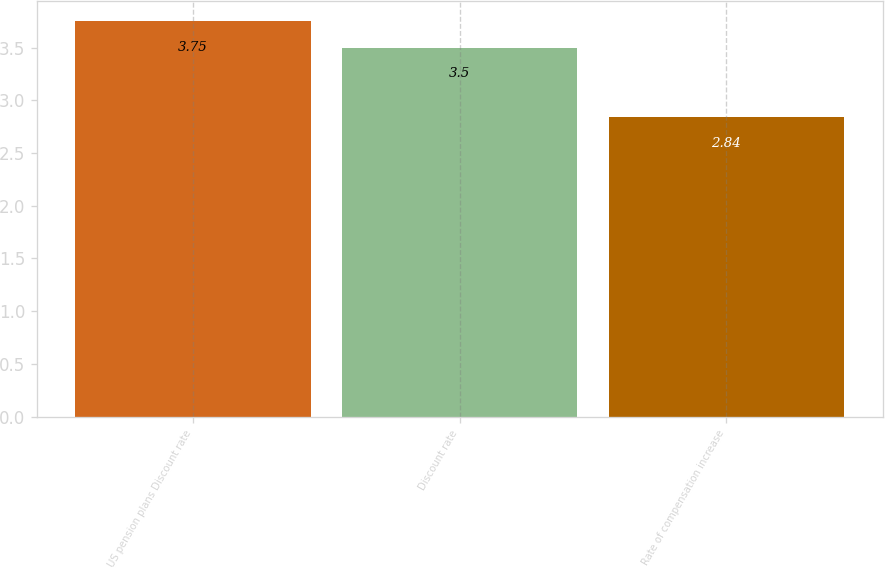<chart> <loc_0><loc_0><loc_500><loc_500><bar_chart><fcel>US pension plans Discount rate<fcel>Discount rate<fcel>Rate of compensation increase<nl><fcel>3.75<fcel>3.5<fcel>2.84<nl></chart> 